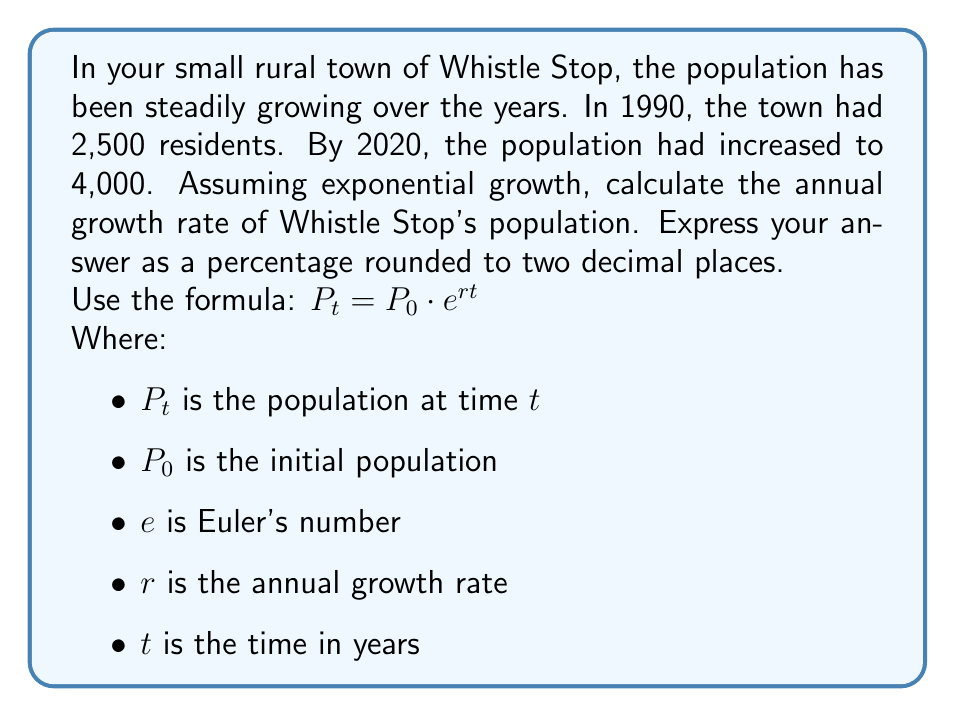Show me your answer to this math problem. Let's approach this step-by-step using logarithms:

1) We're given:
   $P_0 = 2,500$ (population in 1990)
   $P_t = 4,000$ (population in 2020)
   $t = 30$ years (from 1990 to 2020)

2) We'll use the formula: $P_t = P_0 \cdot e^{rt}$

3) Substituting our known values:
   $4,000 = 2,500 \cdot e^{30r}$

4) Divide both sides by 2,500:
   $\frac{4,000}{2,500} = e^{30r}$

5) Take the natural logarithm of both sides:
   $\ln(\frac{4,000}{2,500}) = \ln(e^{30r})$

6) Simplify the right side using the logarithm property $\ln(e^x) = x$:
   $\ln(\frac{4,000}{2,500}) = 30r$

7) Solve for $r$:
   $r = \frac{\ln(\frac{4,000}{2,500})}{30}$

8) Calculate:
   $r = \frac{\ln(1.6)}{30} \approx 0.015574$

9) Convert to a percentage:
   $0.015574 \times 100 \approx 1.56\%$

Therefore, the annual growth rate of Whistle Stop's population is approximately 1.56%.
Answer: 1.56% 